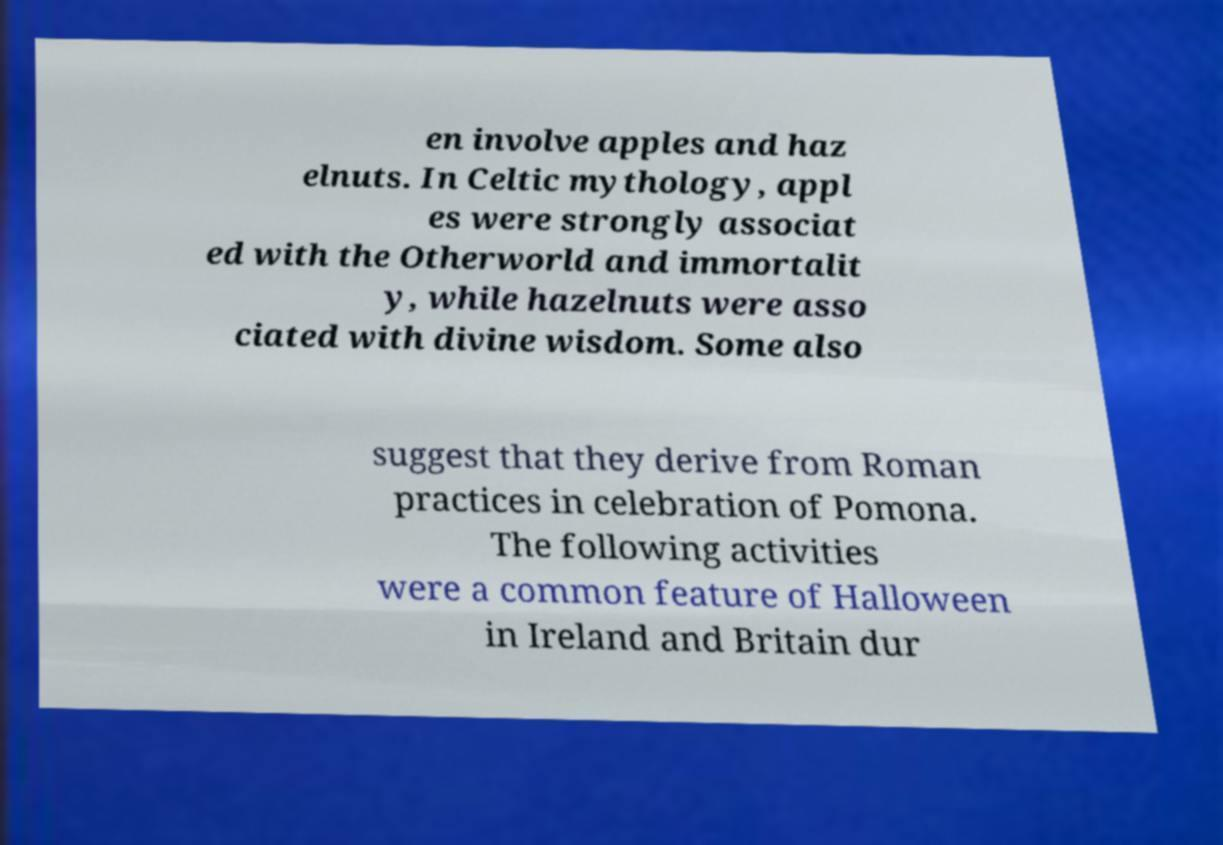For documentation purposes, I need the text within this image transcribed. Could you provide that? en involve apples and haz elnuts. In Celtic mythology, appl es were strongly associat ed with the Otherworld and immortalit y, while hazelnuts were asso ciated with divine wisdom. Some also suggest that they derive from Roman practices in celebration of Pomona. The following activities were a common feature of Halloween in Ireland and Britain dur 